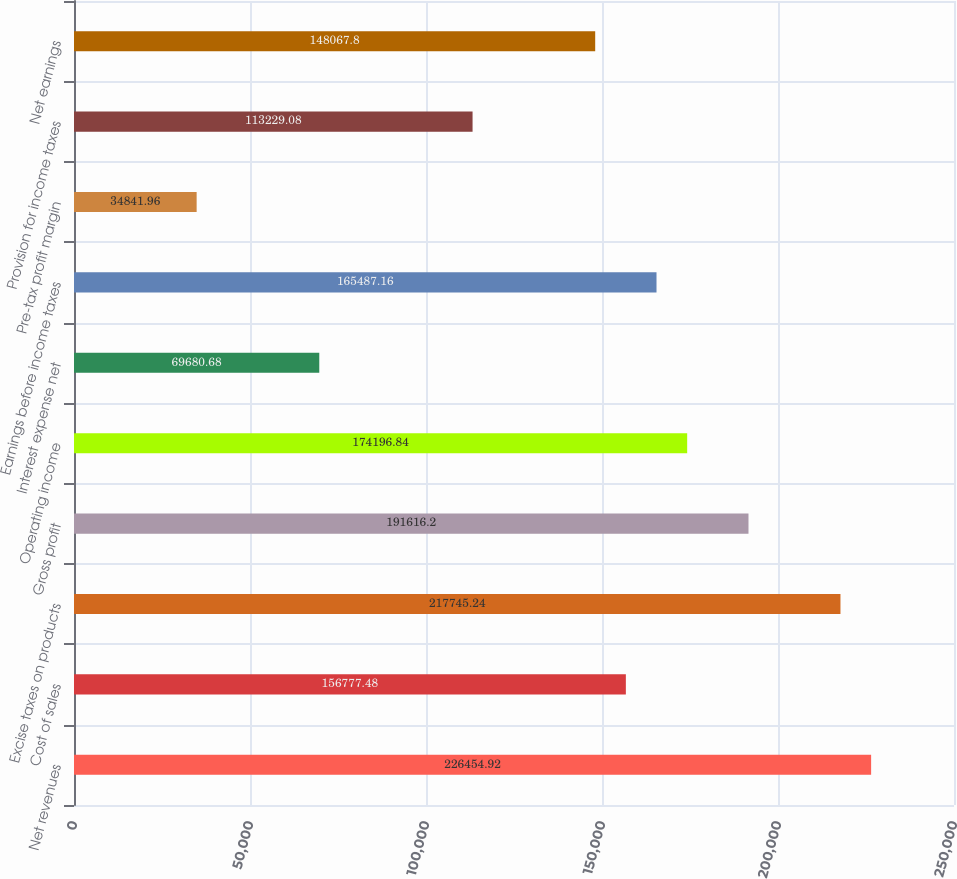Convert chart to OTSL. <chart><loc_0><loc_0><loc_500><loc_500><bar_chart><fcel>Net revenues<fcel>Cost of sales<fcel>Excise taxes on products<fcel>Gross profit<fcel>Operating income<fcel>Interest expense net<fcel>Earnings before income taxes<fcel>Pre-tax profit margin<fcel>Provision for income taxes<fcel>Net earnings<nl><fcel>226455<fcel>156777<fcel>217745<fcel>191616<fcel>174197<fcel>69680.7<fcel>165487<fcel>34842<fcel>113229<fcel>148068<nl></chart> 